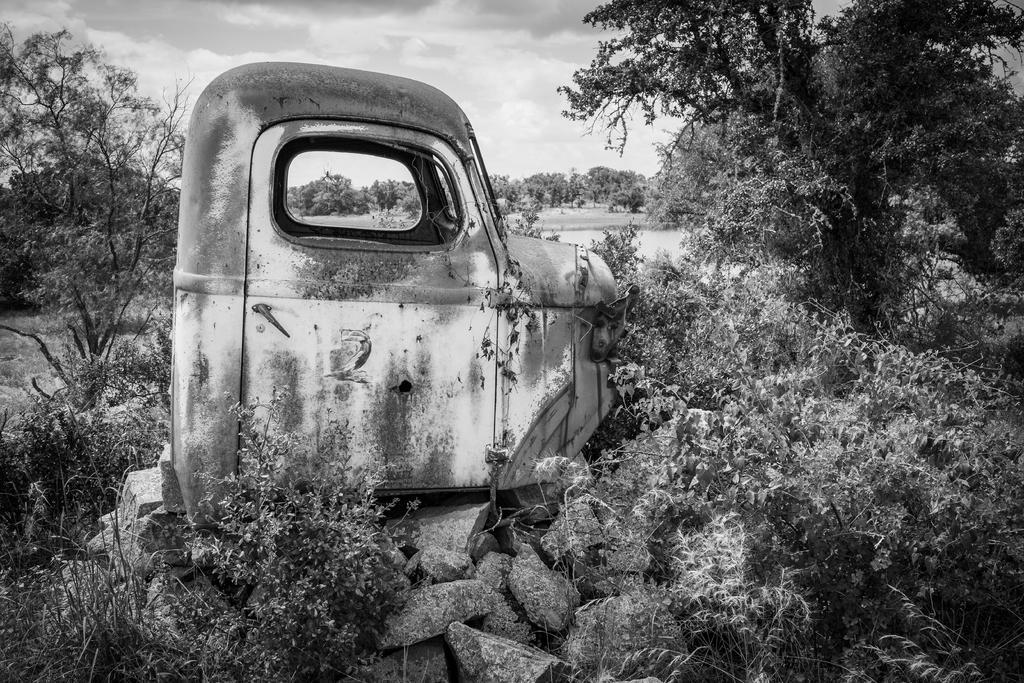In one or two sentences, can you explain what this image depicts? It is the black and white image in which we can see that there is a front part of the truck. There are trees on either side of it. At the bottom there are stones. 